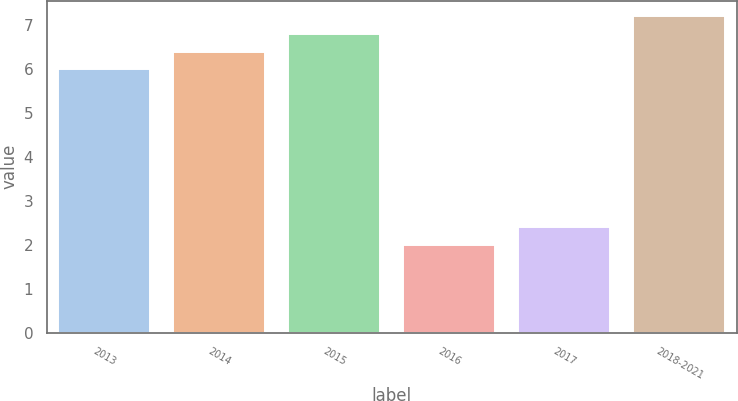<chart> <loc_0><loc_0><loc_500><loc_500><bar_chart><fcel>2013<fcel>2014<fcel>2015<fcel>2016<fcel>2017<fcel>2018-2021<nl><fcel>6<fcel>6.4<fcel>6.8<fcel>2<fcel>2.4<fcel>7.2<nl></chart> 